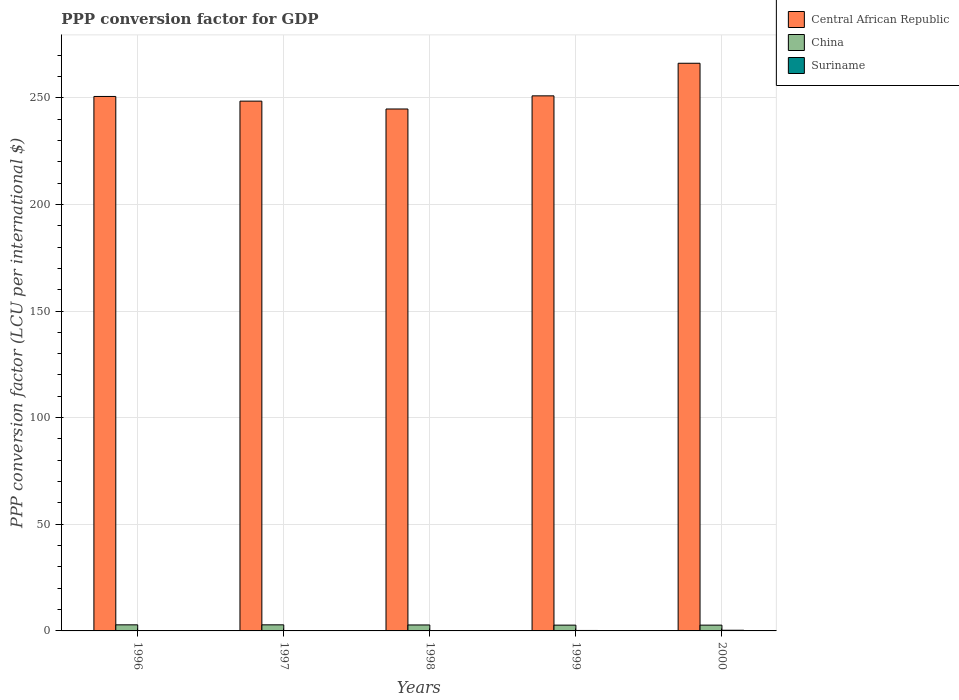How many groups of bars are there?
Offer a terse response. 5. Are the number of bars on each tick of the X-axis equal?
Offer a very short reply. Yes. What is the PPP conversion factor for GDP in Central African Republic in 1999?
Ensure brevity in your answer.  250.87. Across all years, what is the maximum PPP conversion factor for GDP in China?
Your answer should be very brief. 2.85. Across all years, what is the minimum PPP conversion factor for GDP in Suriname?
Ensure brevity in your answer.  0.11. In which year was the PPP conversion factor for GDP in Central African Republic maximum?
Offer a terse response. 2000. In which year was the PPP conversion factor for GDP in Suriname minimum?
Make the answer very short. 1998. What is the total PPP conversion factor for GDP in Central African Republic in the graph?
Your answer should be very brief. 1260.75. What is the difference between the PPP conversion factor for GDP in Central African Republic in 1999 and that in 2000?
Keep it short and to the point. -15.28. What is the difference between the PPP conversion factor for GDP in China in 1998 and the PPP conversion factor for GDP in Suriname in 1996?
Offer a terse response. 2.69. What is the average PPP conversion factor for GDP in China per year?
Offer a very short reply. 2.79. In the year 1998, what is the difference between the PPP conversion factor for GDP in China and PPP conversion factor for GDP in Central African Republic?
Keep it short and to the point. -241.92. In how many years, is the PPP conversion factor for GDP in Suriname greater than 260 LCU?
Your response must be concise. 0. What is the ratio of the PPP conversion factor for GDP in Central African Republic in 1998 to that in 1999?
Keep it short and to the point. 0.98. What is the difference between the highest and the second highest PPP conversion factor for GDP in Suriname?
Keep it short and to the point. 0.11. What is the difference between the highest and the lowest PPP conversion factor for GDP in China?
Make the answer very short. 0.14. In how many years, is the PPP conversion factor for GDP in Suriname greater than the average PPP conversion factor for GDP in Suriname taken over all years?
Offer a very short reply. 2. Is the sum of the PPP conversion factor for GDP in Central African Republic in 1996 and 1998 greater than the maximum PPP conversion factor for GDP in Suriname across all years?
Give a very brief answer. Yes. What does the 2nd bar from the left in 1998 represents?
Provide a short and direct response. China. What does the 3rd bar from the right in 1998 represents?
Offer a terse response. Central African Republic. Is it the case that in every year, the sum of the PPP conversion factor for GDP in Suriname and PPP conversion factor for GDP in China is greater than the PPP conversion factor for GDP in Central African Republic?
Your answer should be very brief. No. How many years are there in the graph?
Keep it short and to the point. 5. Does the graph contain grids?
Your answer should be very brief. Yes. Where does the legend appear in the graph?
Give a very brief answer. Top right. What is the title of the graph?
Your answer should be very brief. PPP conversion factor for GDP. What is the label or title of the X-axis?
Offer a terse response. Years. What is the label or title of the Y-axis?
Offer a terse response. PPP conversion factor (LCU per international $). What is the PPP conversion factor (LCU per international $) of Central African Republic in 1996?
Your response must be concise. 250.59. What is the PPP conversion factor (LCU per international $) of China in 1996?
Your answer should be very brief. 2.85. What is the PPP conversion factor (LCU per international $) in Suriname in 1996?
Make the answer very short. 0.11. What is the PPP conversion factor (LCU per international $) in Central African Republic in 1997?
Ensure brevity in your answer.  248.4. What is the PPP conversion factor (LCU per international $) in China in 1997?
Your answer should be compact. 2.85. What is the PPP conversion factor (LCU per international $) in Suriname in 1997?
Keep it short and to the point. 0.11. What is the PPP conversion factor (LCU per international $) of Central African Republic in 1998?
Offer a very short reply. 244.72. What is the PPP conversion factor (LCU per international $) in China in 1998?
Your answer should be compact. 2.79. What is the PPP conversion factor (LCU per international $) of Suriname in 1998?
Provide a short and direct response. 0.11. What is the PPP conversion factor (LCU per international $) in Central African Republic in 1999?
Your answer should be compact. 250.87. What is the PPP conversion factor (LCU per international $) in China in 1999?
Give a very brief answer. 2.72. What is the PPP conversion factor (LCU per international $) of Suriname in 1999?
Keep it short and to the point. 0.21. What is the PPP conversion factor (LCU per international $) of Central African Republic in 2000?
Keep it short and to the point. 266.16. What is the PPP conversion factor (LCU per international $) in China in 2000?
Offer a terse response. 2.71. What is the PPP conversion factor (LCU per international $) of Suriname in 2000?
Offer a terse response. 0.32. Across all years, what is the maximum PPP conversion factor (LCU per international $) in Central African Republic?
Make the answer very short. 266.16. Across all years, what is the maximum PPP conversion factor (LCU per international $) in China?
Give a very brief answer. 2.85. Across all years, what is the maximum PPP conversion factor (LCU per international $) of Suriname?
Make the answer very short. 0.32. Across all years, what is the minimum PPP conversion factor (LCU per international $) of Central African Republic?
Provide a succinct answer. 244.72. Across all years, what is the minimum PPP conversion factor (LCU per international $) of China?
Your answer should be compact. 2.71. Across all years, what is the minimum PPP conversion factor (LCU per international $) of Suriname?
Your response must be concise. 0.11. What is the total PPP conversion factor (LCU per international $) in Central African Republic in the graph?
Keep it short and to the point. 1260.75. What is the total PPP conversion factor (LCU per international $) of China in the graph?
Your answer should be very brief. 13.93. What is the total PPP conversion factor (LCU per international $) in Suriname in the graph?
Offer a very short reply. 0.85. What is the difference between the PPP conversion factor (LCU per international $) of Central African Republic in 1996 and that in 1997?
Give a very brief answer. 2.19. What is the difference between the PPP conversion factor (LCU per international $) of China in 1996 and that in 1997?
Your answer should be compact. 0. What is the difference between the PPP conversion factor (LCU per international $) in Suriname in 1996 and that in 1997?
Give a very brief answer. -0. What is the difference between the PPP conversion factor (LCU per international $) of Central African Republic in 1996 and that in 1998?
Provide a short and direct response. 5.87. What is the difference between the PPP conversion factor (LCU per international $) in China in 1996 and that in 1998?
Offer a terse response. 0.06. What is the difference between the PPP conversion factor (LCU per international $) of Suriname in 1996 and that in 1998?
Your answer should be compact. 0. What is the difference between the PPP conversion factor (LCU per international $) in Central African Republic in 1996 and that in 1999?
Your answer should be compact. -0.28. What is the difference between the PPP conversion factor (LCU per international $) of China in 1996 and that in 1999?
Make the answer very short. 0.14. What is the difference between the PPP conversion factor (LCU per international $) in Suriname in 1996 and that in 1999?
Provide a succinct answer. -0.11. What is the difference between the PPP conversion factor (LCU per international $) in Central African Republic in 1996 and that in 2000?
Offer a very short reply. -15.57. What is the difference between the PPP conversion factor (LCU per international $) of China in 1996 and that in 2000?
Offer a terse response. 0.14. What is the difference between the PPP conversion factor (LCU per international $) in Suriname in 1996 and that in 2000?
Offer a terse response. -0.21. What is the difference between the PPP conversion factor (LCU per international $) in Central African Republic in 1997 and that in 1998?
Make the answer very short. 3.68. What is the difference between the PPP conversion factor (LCU per international $) in China in 1997 and that in 1998?
Give a very brief answer. 0.06. What is the difference between the PPP conversion factor (LCU per international $) of Suriname in 1997 and that in 1998?
Ensure brevity in your answer.  0. What is the difference between the PPP conversion factor (LCU per international $) in Central African Republic in 1997 and that in 1999?
Your answer should be compact. -2.47. What is the difference between the PPP conversion factor (LCU per international $) in China in 1997 and that in 1999?
Your answer should be very brief. 0.13. What is the difference between the PPP conversion factor (LCU per international $) of Suriname in 1997 and that in 1999?
Make the answer very short. -0.11. What is the difference between the PPP conversion factor (LCU per international $) in Central African Republic in 1997 and that in 2000?
Your answer should be very brief. -17.76. What is the difference between the PPP conversion factor (LCU per international $) of China in 1997 and that in 2000?
Give a very brief answer. 0.14. What is the difference between the PPP conversion factor (LCU per international $) in Suriname in 1997 and that in 2000?
Give a very brief answer. -0.21. What is the difference between the PPP conversion factor (LCU per international $) in Central African Republic in 1998 and that in 1999?
Offer a very short reply. -6.16. What is the difference between the PPP conversion factor (LCU per international $) in China in 1998 and that in 1999?
Ensure brevity in your answer.  0.08. What is the difference between the PPP conversion factor (LCU per international $) of Suriname in 1998 and that in 1999?
Ensure brevity in your answer.  -0.11. What is the difference between the PPP conversion factor (LCU per international $) of Central African Republic in 1998 and that in 2000?
Ensure brevity in your answer.  -21.44. What is the difference between the PPP conversion factor (LCU per international $) of China in 1998 and that in 2000?
Offer a terse response. 0.08. What is the difference between the PPP conversion factor (LCU per international $) of Suriname in 1998 and that in 2000?
Provide a short and direct response. -0.22. What is the difference between the PPP conversion factor (LCU per international $) of Central African Republic in 1999 and that in 2000?
Give a very brief answer. -15.28. What is the difference between the PPP conversion factor (LCU per international $) of China in 1999 and that in 2000?
Give a very brief answer. 0.01. What is the difference between the PPP conversion factor (LCU per international $) of Suriname in 1999 and that in 2000?
Make the answer very short. -0.11. What is the difference between the PPP conversion factor (LCU per international $) in Central African Republic in 1996 and the PPP conversion factor (LCU per international $) in China in 1997?
Your response must be concise. 247.74. What is the difference between the PPP conversion factor (LCU per international $) of Central African Republic in 1996 and the PPP conversion factor (LCU per international $) of Suriname in 1997?
Offer a very short reply. 250.48. What is the difference between the PPP conversion factor (LCU per international $) of China in 1996 and the PPP conversion factor (LCU per international $) of Suriname in 1997?
Keep it short and to the point. 2.75. What is the difference between the PPP conversion factor (LCU per international $) in Central African Republic in 1996 and the PPP conversion factor (LCU per international $) in China in 1998?
Your answer should be very brief. 247.8. What is the difference between the PPP conversion factor (LCU per international $) of Central African Republic in 1996 and the PPP conversion factor (LCU per international $) of Suriname in 1998?
Make the answer very short. 250.48. What is the difference between the PPP conversion factor (LCU per international $) in China in 1996 and the PPP conversion factor (LCU per international $) in Suriname in 1998?
Give a very brief answer. 2.75. What is the difference between the PPP conversion factor (LCU per international $) of Central African Republic in 1996 and the PPP conversion factor (LCU per international $) of China in 1999?
Offer a very short reply. 247.87. What is the difference between the PPP conversion factor (LCU per international $) in Central African Republic in 1996 and the PPP conversion factor (LCU per international $) in Suriname in 1999?
Keep it short and to the point. 250.38. What is the difference between the PPP conversion factor (LCU per international $) in China in 1996 and the PPP conversion factor (LCU per international $) in Suriname in 1999?
Keep it short and to the point. 2.64. What is the difference between the PPP conversion factor (LCU per international $) in Central African Republic in 1996 and the PPP conversion factor (LCU per international $) in China in 2000?
Provide a short and direct response. 247.88. What is the difference between the PPP conversion factor (LCU per international $) of Central African Republic in 1996 and the PPP conversion factor (LCU per international $) of Suriname in 2000?
Make the answer very short. 250.27. What is the difference between the PPP conversion factor (LCU per international $) of China in 1996 and the PPP conversion factor (LCU per international $) of Suriname in 2000?
Offer a very short reply. 2.53. What is the difference between the PPP conversion factor (LCU per international $) in Central African Republic in 1997 and the PPP conversion factor (LCU per international $) in China in 1998?
Offer a very short reply. 245.61. What is the difference between the PPP conversion factor (LCU per international $) in Central African Republic in 1997 and the PPP conversion factor (LCU per international $) in Suriname in 1998?
Your response must be concise. 248.3. What is the difference between the PPP conversion factor (LCU per international $) of China in 1997 and the PPP conversion factor (LCU per international $) of Suriname in 1998?
Keep it short and to the point. 2.74. What is the difference between the PPP conversion factor (LCU per international $) of Central African Republic in 1997 and the PPP conversion factor (LCU per international $) of China in 1999?
Your answer should be very brief. 245.69. What is the difference between the PPP conversion factor (LCU per international $) of Central African Republic in 1997 and the PPP conversion factor (LCU per international $) of Suriname in 1999?
Your answer should be very brief. 248.19. What is the difference between the PPP conversion factor (LCU per international $) of China in 1997 and the PPP conversion factor (LCU per international $) of Suriname in 1999?
Offer a very short reply. 2.64. What is the difference between the PPP conversion factor (LCU per international $) of Central African Republic in 1997 and the PPP conversion factor (LCU per international $) of China in 2000?
Your answer should be compact. 245.69. What is the difference between the PPP conversion factor (LCU per international $) in Central African Republic in 1997 and the PPP conversion factor (LCU per international $) in Suriname in 2000?
Offer a very short reply. 248.08. What is the difference between the PPP conversion factor (LCU per international $) of China in 1997 and the PPP conversion factor (LCU per international $) of Suriname in 2000?
Your answer should be very brief. 2.53. What is the difference between the PPP conversion factor (LCU per international $) of Central African Republic in 1998 and the PPP conversion factor (LCU per international $) of China in 1999?
Offer a terse response. 242. What is the difference between the PPP conversion factor (LCU per international $) of Central African Republic in 1998 and the PPP conversion factor (LCU per international $) of Suriname in 1999?
Give a very brief answer. 244.51. What is the difference between the PPP conversion factor (LCU per international $) in China in 1998 and the PPP conversion factor (LCU per international $) in Suriname in 1999?
Give a very brief answer. 2.58. What is the difference between the PPP conversion factor (LCU per international $) of Central African Republic in 1998 and the PPP conversion factor (LCU per international $) of China in 2000?
Your answer should be compact. 242.01. What is the difference between the PPP conversion factor (LCU per international $) in Central African Republic in 1998 and the PPP conversion factor (LCU per international $) in Suriname in 2000?
Your answer should be very brief. 244.4. What is the difference between the PPP conversion factor (LCU per international $) of China in 1998 and the PPP conversion factor (LCU per international $) of Suriname in 2000?
Ensure brevity in your answer.  2.47. What is the difference between the PPP conversion factor (LCU per international $) of Central African Republic in 1999 and the PPP conversion factor (LCU per international $) of China in 2000?
Provide a succinct answer. 248.16. What is the difference between the PPP conversion factor (LCU per international $) of Central African Republic in 1999 and the PPP conversion factor (LCU per international $) of Suriname in 2000?
Provide a short and direct response. 250.55. What is the difference between the PPP conversion factor (LCU per international $) of China in 1999 and the PPP conversion factor (LCU per international $) of Suriname in 2000?
Your response must be concise. 2.4. What is the average PPP conversion factor (LCU per international $) in Central African Republic per year?
Your answer should be compact. 252.15. What is the average PPP conversion factor (LCU per international $) in China per year?
Give a very brief answer. 2.79. What is the average PPP conversion factor (LCU per international $) in Suriname per year?
Your response must be concise. 0.17. In the year 1996, what is the difference between the PPP conversion factor (LCU per international $) in Central African Republic and PPP conversion factor (LCU per international $) in China?
Your answer should be very brief. 247.74. In the year 1996, what is the difference between the PPP conversion factor (LCU per international $) in Central African Republic and PPP conversion factor (LCU per international $) in Suriname?
Provide a succinct answer. 250.48. In the year 1996, what is the difference between the PPP conversion factor (LCU per international $) in China and PPP conversion factor (LCU per international $) in Suriname?
Give a very brief answer. 2.75. In the year 1997, what is the difference between the PPP conversion factor (LCU per international $) of Central African Republic and PPP conversion factor (LCU per international $) of China?
Your answer should be very brief. 245.55. In the year 1997, what is the difference between the PPP conversion factor (LCU per international $) of Central African Republic and PPP conversion factor (LCU per international $) of Suriname?
Offer a terse response. 248.3. In the year 1997, what is the difference between the PPP conversion factor (LCU per international $) of China and PPP conversion factor (LCU per international $) of Suriname?
Ensure brevity in your answer.  2.74. In the year 1998, what is the difference between the PPP conversion factor (LCU per international $) of Central African Republic and PPP conversion factor (LCU per international $) of China?
Offer a very short reply. 241.92. In the year 1998, what is the difference between the PPP conversion factor (LCU per international $) in Central African Republic and PPP conversion factor (LCU per international $) in Suriname?
Your answer should be compact. 244.61. In the year 1998, what is the difference between the PPP conversion factor (LCU per international $) in China and PPP conversion factor (LCU per international $) in Suriname?
Ensure brevity in your answer.  2.69. In the year 1999, what is the difference between the PPP conversion factor (LCU per international $) in Central African Republic and PPP conversion factor (LCU per international $) in China?
Offer a terse response. 248.16. In the year 1999, what is the difference between the PPP conversion factor (LCU per international $) in Central African Republic and PPP conversion factor (LCU per international $) in Suriname?
Give a very brief answer. 250.66. In the year 1999, what is the difference between the PPP conversion factor (LCU per international $) in China and PPP conversion factor (LCU per international $) in Suriname?
Offer a very short reply. 2.5. In the year 2000, what is the difference between the PPP conversion factor (LCU per international $) in Central African Republic and PPP conversion factor (LCU per international $) in China?
Provide a short and direct response. 263.45. In the year 2000, what is the difference between the PPP conversion factor (LCU per international $) in Central African Republic and PPP conversion factor (LCU per international $) in Suriname?
Ensure brevity in your answer.  265.84. In the year 2000, what is the difference between the PPP conversion factor (LCU per international $) in China and PPP conversion factor (LCU per international $) in Suriname?
Ensure brevity in your answer.  2.39. What is the ratio of the PPP conversion factor (LCU per international $) in Central African Republic in 1996 to that in 1997?
Provide a succinct answer. 1.01. What is the ratio of the PPP conversion factor (LCU per international $) of Suriname in 1996 to that in 1997?
Keep it short and to the point. 1. What is the ratio of the PPP conversion factor (LCU per international $) of China in 1996 to that in 1998?
Your response must be concise. 1.02. What is the ratio of the PPP conversion factor (LCU per international $) in Suriname in 1996 to that in 1998?
Your answer should be compact. 1.01. What is the ratio of the PPP conversion factor (LCU per international $) in Central African Republic in 1996 to that in 1999?
Offer a terse response. 1. What is the ratio of the PPP conversion factor (LCU per international $) in China in 1996 to that in 1999?
Make the answer very short. 1.05. What is the ratio of the PPP conversion factor (LCU per international $) in Suriname in 1996 to that in 1999?
Keep it short and to the point. 0.5. What is the ratio of the PPP conversion factor (LCU per international $) of Central African Republic in 1996 to that in 2000?
Make the answer very short. 0.94. What is the ratio of the PPP conversion factor (LCU per international $) in China in 1996 to that in 2000?
Offer a very short reply. 1.05. What is the ratio of the PPP conversion factor (LCU per international $) in Suriname in 1996 to that in 2000?
Keep it short and to the point. 0.33. What is the ratio of the PPP conversion factor (LCU per international $) in Central African Republic in 1997 to that in 1998?
Give a very brief answer. 1.02. What is the ratio of the PPP conversion factor (LCU per international $) of China in 1997 to that in 1998?
Your response must be concise. 1.02. What is the ratio of the PPP conversion factor (LCU per international $) in Suriname in 1997 to that in 1998?
Offer a very short reply. 1.01. What is the ratio of the PPP conversion factor (LCU per international $) of China in 1997 to that in 1999?
Keep it short and to the point. 1.05. What is the ratio of the PPP conversion factor (LCU per international $) in Suriname in 1997 to that in 1999?
Your response must be concise. 0.5. What is the ratio of the PPP conversion factor (LCU per international $) in China in 1997 to that in 2000?
Give a very brief answer. 1.05. What is the ratio of the PPP conversion factor (LCU per international $) of Suriname in 1997 to that in 2000?
Your answer should be very brief. 0.33. What is the ratio of the PPP conversion factor (LCU per international $) in Central African Republic in 1998 to that in 1999?
Ensure brevity in your answer.  0.98. What is the ratio of the PPP conversion factor (LCU per international $) in China in 1998 to that in 1999?
Provide a succinct answer. 1.03. What is the ratio of the PPP conversion factor (LCU per international $) of Suriname in 1998 to that in 1999?
Your answer should be compact. 0.5. What is the ratio of the PPP conversion factor (LCU per international $) of Central African Republic in 1998 to that in 2000?
Your response must be concise. 0.92. What is the ratio of the PPP conversion factor (LCU per international $) of China in 1998 to that in 2000?
Provide a succinct answer. 1.03. What is the ratio of the PPP conversion factor (LCU per international $) of Suriname in 1998 to that in 2000?
Give a very brief answer. 0.33. What is the ratio of the PPP conversion factor (LCU per international $) in Central African Republic in 1999 to that in 2000?
Your answer should be compact. 0.94. What is the ratio of the PPP conversion factor (LCU per international $) of Suriname in 1999 to that in 2000?
Make the answer very short. 0.66. What is the difference between the highest and the second highest PPP conversion factor (LCU per international $) of Central African Republic?
Give a very brief answer. 15.28. What is the difference between the highest and the second highest PPP conversion factor (LCU per international $) in China?
Provide a succinct answer. 0. What is the difference between the highest and the second highest PPP conversion factor (LCU per international $) of Suriname?
Offer a very short reply. 0.11. What is the difference between the highest and the lowest PPP conversion factor (LCU per international $) in Central African Republic?
Your response must be concise. 21.44. What is the difference between the highest and the lowest PPP conversion factor (LCU per international $) in China?
Offer a terse response. 0.14. What is the difference between the highest and the lowest PPP conversion factor (LCU per international $) in Suriname?
Make the answer very short. 0.22. 